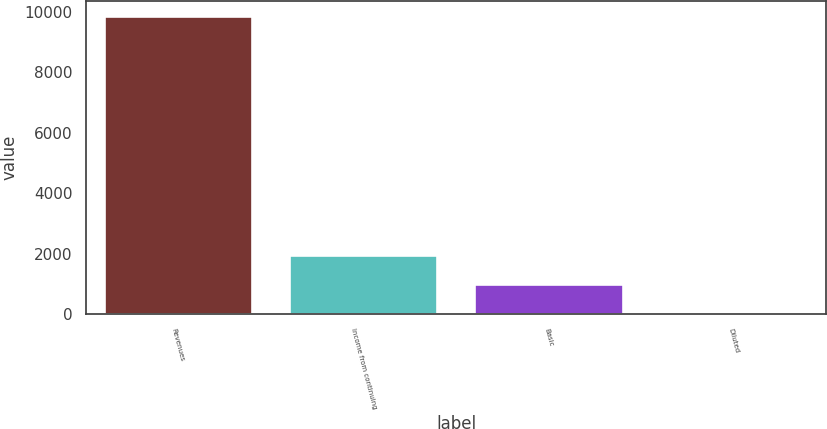Convert chart to OTSL. <chart><loc_0><loc_0><loc_500><loc_500><bar_chart><fcel>Revenues<fcel>Income from continuing<fcel>Basic<fcel>Diluted<nl><fcel>9868<fcel>1975.4<fcel>988.82<fcel>2.24<nl></chart> 